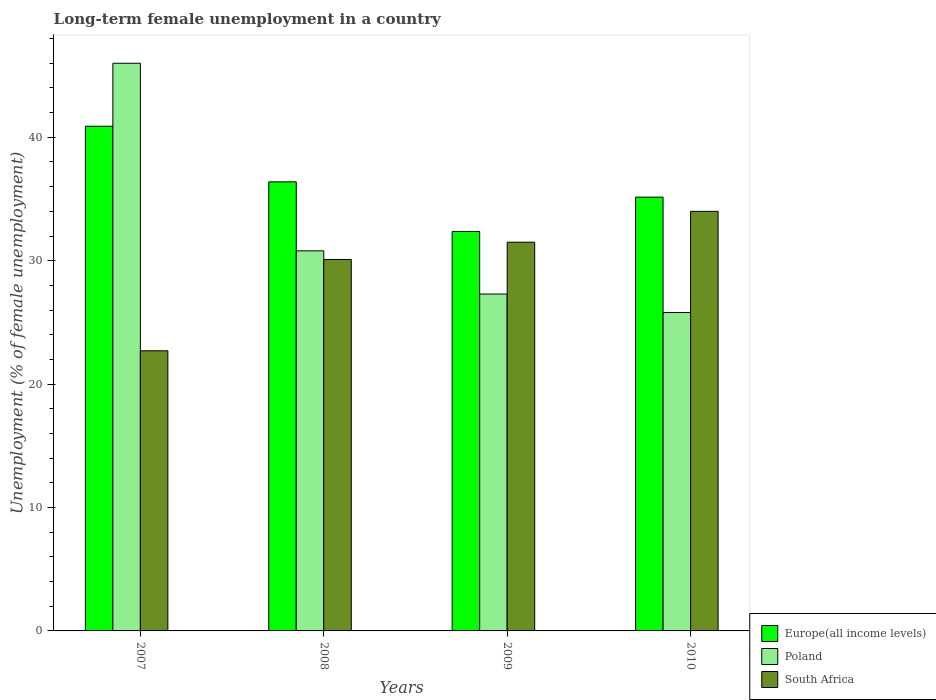How many different coloured bars are there?
Your answer should be compact. 3. How many groups of bars are there?
Keep it short and to the point. 4. Are the number of bars per tick equal to the number of legend labels?
Your answer should be compact. Yes. Are the number of bars on each tick of the X-axis equal?
Your answer should be very brief. Yes. How many bars are there on the 1st tick from the left?
Provide a succinct answer. 3. How many bars are there on the 3rd tick from the right?
Provide a short and direct response. 3. What is the label of the 4th group of bars from the left?
Keep it short and to the point. 2010. What is the percentage of long-term unemployed female population in Europe(all income levels) in 2007?
Keep it short and to the point. 40.9. Across all years, what is the maximum percentage of long-term unemployed female population in Europe(all income levels)?
Keep it short and to the point. 40.9. Across all years, what is the minimum percentage of long-term unemployed female population in Poland?
Your answer should be compact. 25.8. In which year was the percentage of long-term unemployed female population in Europe(all income levels) maximum?
Make the answer very short. 2007. What is the total percentage of long-term unemployed female population in Poland in the graph?
Give a very brief answer. 129.9. What is the difference between the percentage of long-term unemployed female population in South Africa in 2008 and that in 2010?
Make the answer very short. -3.9. What is the difference between the percentage of long-term unemployed female population in Europe(all income levels) in 2007 and the percentage of long-term unemployed female population in Poland in 2008?
Ensure brevity in your answer.  10.1. What is the average percentage of long-term unemployed female population in Europe(all income levels) per year?
Make the answer very short. 36.2. In the year 2008, what is the difference between the percentage of long-term unemployed female population in Europe(all income levels) and percentage of long-term unemployed female population in Poland?
Your answer should be compact. 5.59. What is the ratio of the percentage of long-term unemployed female population in Europe(all income levels) in 2009 to that in 2010?
Offer a terse response. 0.92. What is the difference between the highest and the second highest percentage of long-term unemployed female population in Europe(all income levels)?
Make the answer very short. 4.51. What is the difference between the highest and the lowest percentage of long-term unemployed female population in Europe(all income levels)?
Keep it short and to the point. 8.52. In how many years, is the percentage of long-term unemployed female population in Poland greater than the average percentage of long-term unemployed female population in Poland taken over all years?
Provide a short and direct response. 1. What does the 1st bar from the left in 2007 represents?
Your answer should be compact. Europe(all income levels). What does the 1st bar from the right in 2007 represents?
Provide a short and direct response. South Africa. What is the difference between two consecutive major ticks on the Y-axis?
Keep it short and to the point. 10. Are the values on the major ticks of Y-axis written in scientific E-notation?
Give a very brief answer. No. Does the graph contain grids?
Provide a short and direct response. No. How many legend labels are there?
Offer a terse response. 3. What is the title of the graph?
Offer a terse response. Long-term female unemployment in a country. What is the label or title of the X-axis?
Provide a succinct answer. Years. What is the label or title of the Y-axis?
Provide a short and direct response. Unemployment (% of female unemployment). What is the Unemployment (% of female unemployment) of Europe(all income levels) in 2007?
Keep it short and to the point. 40.9. What is the Unemployment (% of female unemployment) of South Africa in 2007?
Offer a very short reply. 22.7. What is the Unemployment (% of female unemployment) in Europe(all income levels) in 2008?
Offer a very short reply. 36.39. What is the Unemployment (% of female unemployment) of Poland in 2008?
Your response must be concise. 30.8. What is the Unemployment (% of female unemployment) in South Africa in 2008?
Provide a short and direct response. 30.1. What is the Unemployment (% of female unemployment) of Europe(all income levels) in 2009?
Give a very brief answer. 32.37. What is the Unemployment (% of female unemployment) in Poland in 2009?
Offer a very short reply. 27.3. What is the Unemployment (% of female unemployment) in South Africa in 2009?
Provide a short and direct response. 31.5. What is the Unemployment (% of female unemployment) of Europe(all income levels) in 2010?
Provide a succinct answer. 35.15. What is the Unemployment (% of female unemployment) of Poland in 2010?
Provide a short and direct response. 25.8. What is the Unemployment (% of female unemployment) of South Africa in 2010?
Your answer should be compact. 34. Across all years, what is the maximum Unemployment (% of female unemployment) in Europe(all income levels)?
Make the answer very short. 40.9. Across all years, what is the maximum Unemployment (% of female unemployment) in Poland?
Your response must be concise. 46. Across all years, what is the maximum Unemployment (% of female unemployment) in South Africa?
Offer a very short reply. 34. Across all years, what is the minimum Unemployment (% of female unemployment) in Europe(all income levels)?
Your response must be concise. 32.37. Across all years, what is the minimum Unemployment (% of female unemployment) of Poland?
Make the answer very short. 25.8. Across all years, what is the minimum Unemployment (% of female unemployment) of South Africa?
Your response must be concise. 22.7. What is the total Unemployment (% of female unemployment) in Europe(all income levels) in the graph?
Your answer should be compact. 144.81. What is the total Unemployment (% of female unemployment) of Poland in the graph?
Your answer should be very brief. 129.9. What is the total Unemployment (% of female unemployment) of South Africa in the graph?
Your answer should be very brief. 118.3. What is the difference between the Unemployment (% of female unemployment) of Europe(all income levels) in 2007 and that in 2008?
Provide a succinct answer. 4.51. What is the difference between the Unemployment (% of female unemployment) of Poland in 2007 and that in 2008?
Give a very brief answer. 15.2. What is the difference between the Unemployment (% of female unemployment) of Europe(all income levels) in 2007 and that in 2009?
Make the answer very short. 8.52. What is the difference between the Unemployment (% of female unemployment) in Poland in 2007 and that in 2009?
Offer a very short reply. 18.7. What is the difference between the Unemployment (% of female unemployment) in South Africa in 2007 and that in 2009?
Ensure brevity in your answer.  -8.8. What is the difference between the Unemployment (% of female unemployment) in Europe(all income levels) in 2007 and that in 2010?
Your answer should be compact. 5.74. What is the difference between the Unemployment (% of female unemployment) in Poland in 2007 and that in 2010?
Your response must be concise. 20.2. What is the difference between the Unemployment (% of female unemployment) in Europe(all income levels) in 2008 and that in 2009?
Ensure brevity in your answer.  4.02. What is the difference between the Unemployment (% of female unemployment) of Poland in 2008 and that in 2009?
Offer a very short reply. 3.5. What is the difference between the Unemployment (% of female unemployment) of South Africa in 2008 and that in 2009?
Ensure brevity in your answer.  -1.4. What is the difference between the Unemployment (% of female unemployment) in Europe(all income levels) in 2008 and that in 2010?
Give a very brief answer. 1.24. What is the difference between the Unemployment (% of female unemployment) in Europe(all income levels) in 2009 and that in 2010?
Your answer should be very brief. -2.78. What is the difference between the Unemployment (% of female unemployment) of South Africa in 2009 and that in 2010?
Give a very brief answer. -2.5. What is the difference between the Unemployment (% of female unemployment) of Europe(all income levels) in 2007 and the Unemployment (% of female unemployment) of Poland in 2008?
Your answer should be very brief. 10.1. What is the difference between the Unemployment (% of female unemployment) in Europe(all income levels) in 2007 and the Unemployment (% of female unemployment) in South Africa in 2008?
Give a very brief answer. 10.8. What is the difference between the Unemployment (% of female unemployment) of Europe(all income levels) in 2007 and the Unemployment (% of female unemployment) of Poland in 2009?
Provide a short and direct response. 13.6. What is the difference between the Unemployment (% of female unemployment) of Europe(all income levels) in 2007 and the Unemployment (% of female unemployment) of South Africa in 2009?
Your answer should be very brief. 9.4. What is the difference between the Unemployment (% of female unemployment) of Europe(all income levels) in 2007 and the Unemployment (% of female unemployment) of Poland in 2010?
Keep it short and to the point. 15.1. What is the difference between the Unemployment (% of female unemployment) of Europe(all income levels) in 2007 and the Unemployment (% of female unemployment) of South Africa in 2010?
Give a very brief answer. 6.9. What is the difference between the Unemployment (% of female unemployment) of Poland in 2007 and the Unemployment (% of female unemployment) of South Africa in 2010?
Offer a very short reply. 12. What is the difference between the Unemployment (% of female unemployment) of Europe(all income levels) in 2008 and the Unemployment (% of female unemployment) of Poland in 2009?
Your answer should be very brief. 9.09. What is the difference between the Unemployment (% of female unemployment) of Europe(all income levels) in 2008 and the Unemployment (% of female unemployment) of South Africa in 2009?
Your response must be concise. 4.89. What is the difference between the Unemployment (% of female unemployment) of Europe(all income levels) in 2008 and the Unemployment (% of female unemployment) of Poland in 2010?
Your response must be concise. 10.59. What is the difference between the Unemployment (% of female unemployment) in Europe(all income levels) in 2008 and the Unemployment (% of female unemployment) in South Africa in 2010?
Provide a short and direct response. 2.39. What is the difference between the Unemployment (% of female unemployment) of Poland in 2008 and the Unemployment (% of female unemployment) of South Africa in 2010?
Keep it short and to the point. -3.2. What is the difference between the Unemployment (% of female unemployment) in Europe(all income levels) in 2009 and the Unemployment (% of female unemployment) in Poland in 2010?
Provide a short and direct response. 6.57. What is the difference between the Unemployment (% of female unemployment) of Europe(all income levels) in 2009 and the Unemployment (% of female unemployment) of South Africa in 2010?
Offer a very short reply. -1.63. What is the difference between the Unemployment (% of female unemployment) in Poland in 2009 and the Unemployment (% of female unemployment) in South Africa in 2010?
Keep it short and to the point. -6.7. What is the average Unemployment (% of female unemployment) in Europe(all income levels) per year?
Your answer should be very brief. 36.2. What is the average Unemployment (% of female unemployment) in Poland per year?
Provide a short and direct response. 32.48. What is the average Unemployment (% of female unemployment) in South Africa per year?
Provide a short and direct response. 29.57. In the year 2007, what is the difference between the Unemployment (% of female unemployment) of Europe(all income levels) and Unemployment (% of female unemployment) of Poland?
Your answer should be compact. -5.1. In the year 2007, what is the difference between the Unemployment (% of female unemployment) in Europe(all income levels) and Unemployment (% of female unemployment) in South Africa?
Offer a terse response. 18.2. In the year 2007, what is the difference between the Unemployment (% of female unemployment) of Poland and Unemployment (% of female unemployment) of South Africa?
Your response must be concise. 23.3. In the year 2008, what is the difference between the Unemployment (% of female unemployment) in Europe(all income levels) and Unemployment (% of female unemployment) in Poland?
Provide a succinct answer. 5.59. In the year 2008, what is the difference between the Unemployment (% of female unemployment) in Europe(all income levels) and Unemployment (% of female unemployment) in South Africa?
Offer a very short reply. 6.29. In the year 2008, what is the difference between the Unemployment (% of female unemployment) of Poland and Unemployment (% of female unemployment) of South Africa?
Provide a short and direct response. 0.7. In the year 2009, what is the difference between the Unemployment (% of female unemployment) of Europe(all income levels) and Unemployment (% of female unemployment) of Poland?
Keep it short and to the point. 5.07. In the year 2009, what is the difference between the Unemployment (% of female unemployment) of Europe(all income levels) and Unemployment (% of female unemployment) of South Africa?
Your response must be concise. 0.87. In the year 2010, what is the difference between the Unemployment (% of female unemployment) in Europe(all income levels) and Unemployment (% of female unemployment) in Poland?
Your response must be concise. 9.35. In the year 2010, what is the difference between the Unemployment (% of female unemployment) of Europe(all income levels) and Unemployment (% of female unemployment) of South Africa?
Ensure brevity in your answer.  1.15. In the year 2010, what is the difference between the Unemployment (% of female unemployment) in Poland and Unemployment (% of female unemployment) in South Africa?
Give a very brief answer. -8.2. What is the ratio of the Unemployment (% of female unemployment) in Europe(all income levels) in 2007 to that in 2008?
Offer a terse response. 1.12. What is the ratio of the Unemployment (% of female unemployment) in Poland in 2007 to that in 2008?
Give a very brief answer. 1.49. What is the ratio of the Unemployment (% of female unemployment) of South Africa in 2007 to that in 2008?
Give a very brief answer. 0.75. What is the ratio of the Unemployment (% of female unemployment) in Europe(all income levels) in 2007 to that in 2009?
Ensure brevity in your answer.  1.26. What is the ratio of the Unemployment (% of female unemployment) in Poland in 2007 to that in 2009?
Your response must be concise. 1.69. What is the ratio of the Unemployment (% of female unemployment) of South Africa in 2007 to that in 2009?
Ensure brevity in your answer.  0.72. What is the ratio of the Unemployment (% of female unemployment) of Europe(all income levels) in 2007 to that in 2010?
Provide a succinct answer. 1.16. What is the ratio of the Unemployment (% of female unemployment) of Poland in 2007 to that in 2010?
Ensure brevity in your answer.  1.78. What is the ratio of the Unemployment (% of female unemployment) in South Africa in 2007 to that in 2010?
Ensure brevity in your answer.  0.67. What is the ratio of the Unemployment (% of female unemployment) in Europe(all income levels) in 2008 to that in 2009?
Provide a succinct answer. 1.12. What is the ratio of the Unemployment (% of female unemployment) of Poland in 2008 to that in 2009?
Keep it short and to the point. 1.13. What is the ratio of the Unemployment (% of female unemployment) of South Africa in 2008 to that in 2009?
Provide a short and direct response. 0.96. What is the ratio of the Unemployment (% of female unemployment) in Europe(all income levels) in 2008 to that in 2010?
Your response must be concise. 1.04. What is the ratio of the Unemployment (% of female unemployment) of Poland in 2008 to that in 2010?
Keep it short and to the point. 1.19. What is the ratio of the Unemployment (% of female unemployment) of South Africa in 2008 to that in 2010?
Ensure brevity in your answer.  0.89. What is the ratio of the Unemployment (% of female unemployment) in Europe(all income levels) in 2009 to that in 2010?
Offer a very short reply. 0.92. What is the ratio of the Unemployment (% of female unemployment) in Poland in 2009 to that in 2010?
Your response must be concise. 1.06. What is the ratio of the Unemployment (% of female unemployment) in South Africa in 2009 to that in 2010?
Give a very brief answer. 0.93. What is the difference between the highest and the second highest Unemployment (% of female unemployment) of Europe(all income levels)?
Your response must be concise. 4.51. What is the difference between the highest and the second highest Unemployment (% of female unemployment) in Poland?
Give a very brief answer. 15.2. What is the difference between the highest and the second highest Unemployment (% of female unemployment) in South Africa?
Keep it short and to the point. 2.5. What is the difference between the highest and the lowest Unemployment (% of female unemployment) in Europe(all income levels)?
Provide a short and direct response. 8.52. What is the difference between the highest and the lowest Unemployment (% of female unemployment) in Poland?
Make the answer very short. 20.2. 